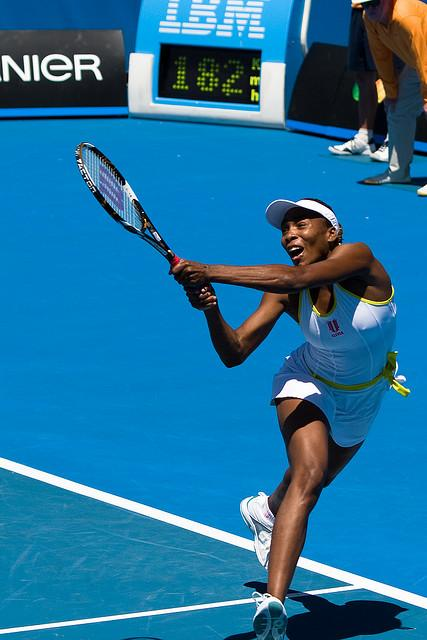What is her sister's name? serena 